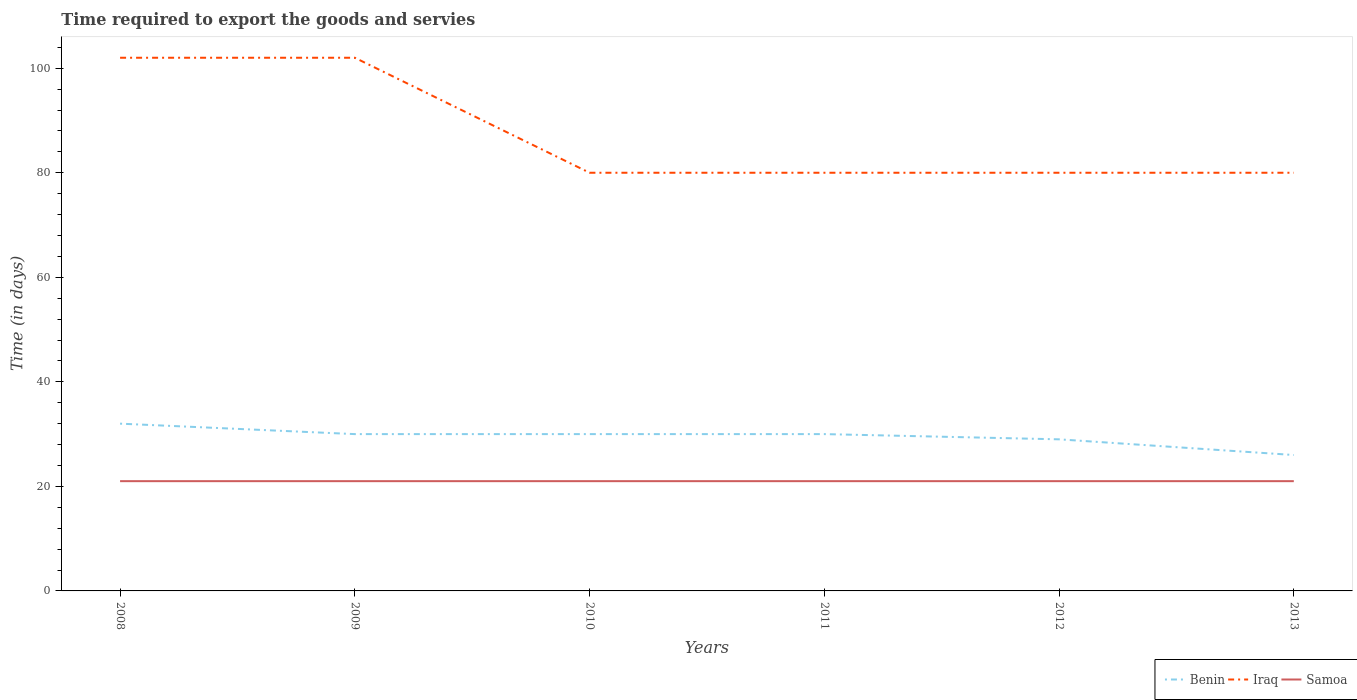How many different coloured lines are there?
Provide a short and direct response. 3. Does the line corresponding to Iraq intersect with the line corresponding to Samoa?
Keep it short and to the point. No. Across all years, what is the maximum number of days required to export the goods and services in Samoa?
Offer a very short reply. 21. What is the total number of days required to export the goods and services in Iraq in the graph?
Offer a very short reply. 22. What is the difference between the highest and the second highest number of days required to export the goods and services in Iraq?
Offer a very short reply. 22. How many lines are there?
Offer a terse response. 3. How many years are there in the graph?
Offer a terse response. 6. Does the graph contain any zero values?
Provide a short and direct response. No. Does the graph contain grids?
Offer a terse response. No. Where does the legend appear in the graph?
Provide a succinct answer. Bottom right. How are the legend labels stacked?
Ensure brevity in your answer.  Horizontal. What is the title of the graph?
Your answer should be compact. Time required to export the goods and servies. Does "Hungary" appear as one of the legend labels in the graph?
Ensure brevity in your answer.  No. What is the label or title of the X-axis?
Keep it short and to the point. Years. What is the label or title of the Y-axis?
Provide a succinct answer. Time (in days). What is the Time (in days) of Iraq in 2008?
Offer a very short reply. 102. What is the Time (in days) of Samoa in 2008?
Provide a short and direct response. 21. What is the Time (in days) in Iraq in 2009?
Offer a very short reply. 102. What is the Time (in days) in Samoa in 2009?
Your response must be concise. 21. What is the Time (in days) of Benin in 2010?
Provide a succinct answer. 30. What is the Time (in days) in Benin in 2011?
Your answer should be compact. 30. What is the Time (in days) in Iraq in 2011?
Provide a succinct answer. 80. What is the Time (in days) in Benin in 2012?
Provide a succinct answer. 29. What is the Time (in days) in Samoa in 2012?
Give a very brief answer. 21. What is the Time (in days) in Benin in 2013?
Give a very brief answer. 26. What is the Time (in days) of Iraq in 2013?
Your response must be concise. 80. Across all years, what is the maximum Time (in days) of Benin?
Make the answer very short. 32. Across all years, what is the maximum Time (in days) of Iraq?
Offer a very short reply. 102. Across all years, what is the maximum Time (in days) of Samoa?
Provide a succinct answer. 21. Across all years, what is the minimum Time (in days) in Benin?
Give a very brief answer. 26. Across all years, what is the minimum Time (in days) of Iraq?
Your response must be concise. 80. Across all years, what is the minimum Time (in days) of Samoa?
Your answer should be very brief. 21. What is the total Time (in days) of Benin in the graph?
Provide a succinct answer. 177. What is the total Time (in days) of Iraq in the graph?
Keep it short and to the point. 524. What is the total Time (in days) in Samoa in the graph?
Ensure brevity in your answer.  126. What is the difference between the Time (in days) in Iraq in 2008 and that in 2009?
Make the answer very short. 0. What is the difference between the Time (in days) of Samoa in 2008 and that in 2010?
Provide a succinct answer. 0. What is the difference between the Time (in days) of Benin in 2008 and that in 2011?
Ensure brevity in your answer.  2. What is the difference between the Time (in days) of Benin in 2008 and that in 2012?
Keep it short and to the point. 3. What is the difference between the Time (in days) of Benin in 2008 and that in 2013?
Provide a short and direct response. 6. What is the difference between the Time (in days) of Iraq in 2008 and that in 2013?
Your answer should be compact. 22. What is the difference between the Time (in days) in Benin in 2009 and that in 2010?
Your answer should be compact. 0. What is the difference between the Time (in days) in Samoa in 2009 and that in 2010?
Provide a short and direct response. 0. What is the difference between the Time (in days) in Benin in 2009 and that in 2011?
Provide a succinct answer. 0. What is the difference between the Time (in days) of Iraq in 2009 and that in 2011?
Your response must be concise. 22. What is the difference between the Time (in days) in Samoa in 2009 and that in 2011?
Give a very brief answer. 0. What is the difference between the Time (in days) of Benin in 2009 and that in 2013?
Your response must be concise. 4. What is the difference between the Time (in days) in Samoa in 2009 and that in 2013?
Offer a terse response. 0. What is the difference between the Time (in days) in Iraq in 2010 and that in 2011?
Give a very brief answer. 0. What is the difference between the Time (in days) of Samoa in 2010 and that in 2011?
Your answer should be very brief. 0. What is the difference between the Time (in days) of Benin in 2010 and that in 2013?
Your answer should be very brief. 4. What is the difference between the Time (in days) of Samoa in 2010 and that in 2013?
Provide a succinct answer. 0. What is the difference between the Time (in days) in Benin in 2011 and that in 2012?
Offer a terse response. 1. What is the difference between the Time (in days) of Iraq in 2011 and that in 2012?
Ensure brevity in your answer.  0. What is the difference between the Time (in days) of Samoa in 2011 and that in 2012?
Provide a short and direct response. 0. What is the difference between the Time (in days) of Benin in 2011 and that in 2013?
Your response must be concise. 4. What is the difference between the Time (in days) in Samoa in 2011 and that in 2013?
Make the answer very short. 0. What is the difference between the Time (in days) in Benin in 2008 and the Time (in days) in Iraq in 2009?
Your answer should be very brief. -70. What is the difference between the Time (in days) of Benin in 2008 and the Time (in days) of Samoa in 2009?
Your answer should be compact. 11. What is the difference between the Time (in days) of Benin in 2008 and the Time (in days) of Iraq in 2010?
Offer a terse response. -48. What is the difference between the Time (in days) in Benin in 2008 and the Time (in days) in Samoa in 2010?
Your answer should be compact. 11. What is the difference between the Time (in days) in Benin in 2008 and the Time (in days) in Iraq in 2011?
Ensure brevity in your answer.  -48. What is the difference between the Time (in days) in Iraq in 2008 and the Time (in days) in Samoa in 2011?
Give a very brief answer. 81. What is the difference between the Time (in days) of Benin in 2008 and the Time (in days) of Iraq in 2012?
Your response must be concise. -48. What is the difference between the Time (in days) of Benin in 2008 and the Time (in days) of Samoa in 2012?
Keep it short and to the point. 11. What is the difference between the Time (in days) in Iraq in 2008 and the Time (in days) in Samoa in 2012?
Make the answer very short. 81. What is the difference between the Time (in days) in Benin in 2008 and the Time (in days) in Iraq in 2013?
Provide a succinct answer. -48. What is the difference between the Time (in days) in Benin in 2008 and the Time (in days) in Samoa in 2013?
Your response must be concise. 11. What is the difference between the Time (in days) of Iraq in 2008 and the Time (in days) of Samoa in 2013?
Ensure brevity in your answer.  81. What is the difference between the Time (in days) of Benin in 2009 and the Time (in days) of Samoa in 2010?
Ensure brevity in your answer.  9. What is the difference between the Time (in days) in Benin in 2009 and the Time (in days) in Iraq in 2011?
Ensure brevity in your answer.  -50. What is the difference between the Time (in days) of Benin in 2009 and the Time (in days) of Samoa in 2011?
Your response must be concise. 9. What is the difference between the Time (in days) of Benin in 2009 and the Time (in days) of Samoa in 2012?
Provide a succinct answer. 9. What is the difference between the Time (in days) of Iraq in 2009 and the Time (in days) of Samoa in 2012?
Give a very brief answer. 81. What is the difference between the Time (in days) in Benin in 2009 and the Time (in days) in Iraq in 2013?
Your answer should be compact. -50. What is the difference between the Time (in days) of Benin in 2009 and the Time (in days) of Samoa in 2013?
Make the answer very short. 9. What is the difference between the Time (in days) of Iraq in 2009 and the Time (in days) of Samoa in 2013?
Your answer should be very brief. 81. What is the difference between the Time (in days) of Benin in 2010 and the Time (in days) of Iraq in 2011?
Offer a terse response. -50. What is the difference between the Time (in days) of Benin in 2010 and the Time (in days) of Samoa in 2011?
Provide a succinct answer. 9. What is the difference between the Time (in days) in Benin in 2010 and the Time (in days) in Iraq in 2012?
Provide a short and direct response. -50. What is the difference between the Time (in days) in Benin in 2010 and the Time (in days) in Iraq in 2013?
Ensure brevity in your answer.  -50. What is the difference between the Time (in days) of Iraq in 2010 and the Time (in days) of Samoa in 2013?
Keep it short and to the point. 59. What is the difference between the Time (in days) of Benin in 2012 and the Time (in days) of Iraq in 2013?
Keep it short and to the point. -51. What is the difference between the Time (in days) in Benin in 2012 and the Time (in days) in Samoa in 2013?
Your response must be concise. 8. What is the average Time (in days) in Benin per year?
Provide a succinct answer. 29.5. What is the average Time (in days) of Iraq per year?
Keep it short and to the point. 87.33. What is the average Time (in days) in Samoa per year?
Give a very brief answer. 21. In the year 2008, what is the difference between the Time (in days) in Benin and Time (in days) in Iraq?
Give a very brief answer. -70. In the year 2008, what is the difference between the Time (in days) of Benin and Time (in days) of Samoa?
Your response must be concise. 11. In the year 2008, what is the difference between the Time (in days) in Iraq and Time (in days) in Samoa?
Provide a short and direct response. 81. In the year 2009, what is the difference between the Time (in days) in Benin and Time (in days) in Iraq?
Provide a succinct answer. -72. In the year 2009, what is the difference between the Time (in days) of Iraq and Time (in days) of Samoa?
Your answer should be very brief. 81. In the year 2010, what is the difference between the Time (in days) of Benin and Time (in days) of Samoa?
Keep it short and to the point. 9. In the year 2010, what is the difference between the Time (in days) in Iraq and Time (in days) in Samoa?
Keep it short and to the point. 59. In the year 2011, what is the difference between the Time (in days) of Benin and Time (in days) of Iraq?
Offer a terse response. -50. In the year 2011, what is the difference between the Time (in days) in Benin and Time (in days) in Samoa?
Offer a very short reply. 9. In the year 2012, what is the difference between the Time (in days) in Benin and Time (in days) in Iraq?
Keep it short and to the point. -51. In the year 2013, what is the difference between the Time (in days) of Benin and Time (in days) of Iraq?
Your answer should be compact. -54. What is the ratio of the Time (in days) in Benin in 2008 to that in 2009?
Offer a terse response. 1.07. What is the ratio of the Time (in days) of Benin in 2008 to that in 2010?
Ensure brevity in your answer.  1.07. What is the ratio of the Time (in days) of Iraq in 2008 to that in 2010?
Provide a short and direct response. 1.27. What is the ratio of the Time (in days) in Samoa in 2008 to that in 2010?
Provide a succinct answer. 1. What is the ratio of the Time (in days) in Benin in 2008 to that in 2011?
Provide a short and direct response. 1.07. What is the ratio of the Time (in days) of Iraq in 2008 to that in 2011?
Make the answer very short. 1.27. What is the ratio of the Time (in days) of Benin in 2008 to that in 2012?
Offer a very short reply. 1.1. What is the ratio of the Time (in days) in Iraq in 2008 to that in 2012?
Give a very brief answer. 1.27. What is the ratio of the Time (in days) in Samoa in 2008 to that in 2012?
Make the answer very short. 1. What is the ratio of the Time (in days) in Benin in 2008 to that in 2013?
Provide a succinct answer. 1.23. What is the ratio of the Time (in days) in Iraq in 2008 to that in 2013?
Provide a succinct answer. 1.27. What is the ratio of the Time (in days) in Samoa in 2008 to that in 2013?
Your answer should be very brief. 1. What is the ratio of the Time (in days) of Iraq in 2009 to that in 2010?
Provide a succinct answer. 1.27. What is the ratio of the Time (in days) in Iraq in 2009 to that in 2011?
Offer a very short reply. 1.27. What is the ratio of the Time (in days) in Benin in 2009 to that in 2012?
Provide a short and direct response. 1.03. What is the ratio of the Time (in days) in Iraq in 2009 to that in 2012?
Make the answer very short. 1.27. What is the ratio of the Time (in days) in Samoa in 2009 to that in 2012?
Your response must be concise. 1. What is the ratio of the Time (in days) in Benin in 2009 to that in 2013?
Give a very brief answer. 1.15. What is the ratio of the Time (in days) in Iraq in 2009 to that in 2013?
Your answer should be very brief. 1.27. What is the ratio of the Time (in days) of Samoa in 2009 to that in 2013?
Your response must be concise. 1. What is the ratio of the Time (in days) in Samoa in 2010 to that in 2011?
Provide a succinct answer. 1. What is the ratio of the Time (in days) of Benin in 2010 to that in 2012?
Give a very brief answer. 1.03. What is the ratio of the Time (in days) of Iraq in 2010 to that in 2012?
Provide a short and direct response. 1. What is the ratio of the Time (in days) in Samoa in 2010 to that in 2012?
Make the answer very short. 1. What is the ratio of the Time (in days) in Benin in 2010 to that in 2013?
Provide a succinct answer. 1.15. What is the ratio of the Time (in days) of Benin in 2011 to that in 2012?
Your answer should be very brief. 1.03. What is the ratio of the Time (in days) of Benin in 2011 to that in 2013?
Keep it short and to the point. 1.15. What is the ratio of the Time (in days) in Iraq in 2011 to that in 2013?
Provide a succinct answer. 1. What is the ratio of the Time (in days) of Samoa in 2011 to that in 2013?
Ensure brevity in your answer.  1. What is the ratio of the Time (in days) in Benin in 2012 to that in 2013?
Offer a very short reply. 1.12. What is the ratio of the Time (in days) in Samoa in 2012 to that in 2013?
Make the answer very short. 1. What is the difference between the highest and the lowest Time (in days) in Iraq?
Make the answer very short. 22. What is the difference between the highest and the lowest Time (in days) in Samoa?
Give a very brief answer. 0. 